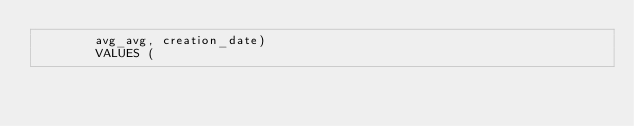Convert code to text. <code><loc_0><loc_0><loc_500><loc_500><_SQL_>				avg_avg, creation_date) 
				VALUES ( </code> 